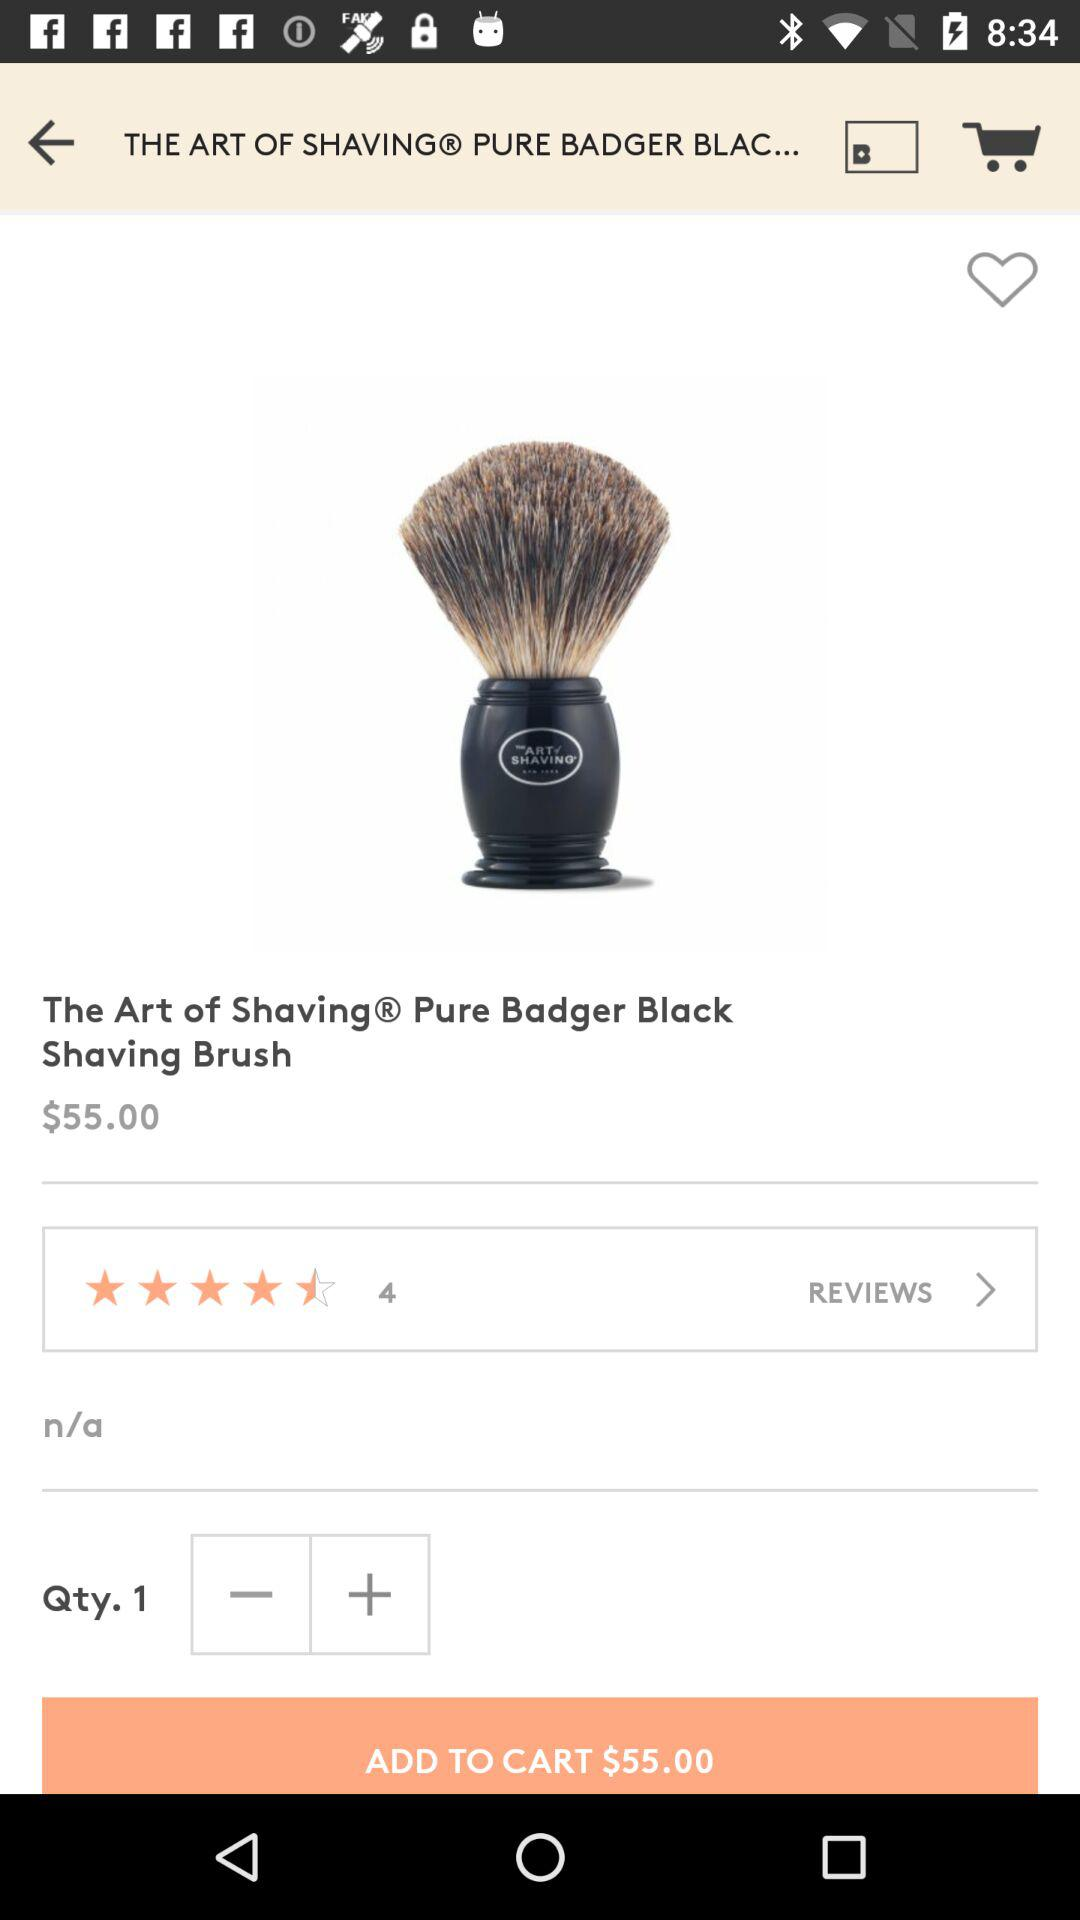How many reviews on badger black shaving brushes are available? There are 4 reviews. 